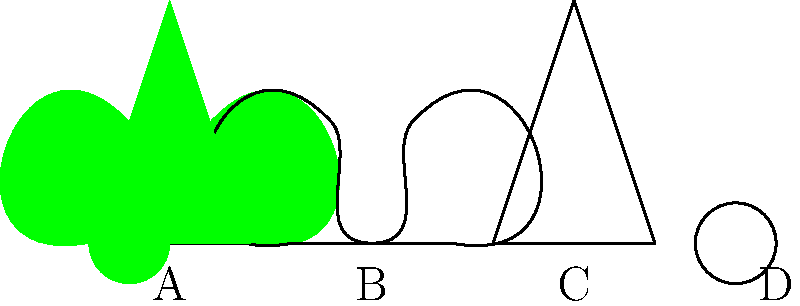In your therapeutic gardening program, you're teaching participants to identify plant species based on leaf shapes. Which of the leaf shapes shown above (A, B, C, or D) is most likely to belong to a maple tree, known for its distinctive lobed leaves? To identify the leaf shape most likely belonging to a maple tree, let's analyze each option:

1. Leaf A: This leaf has a simple, triangular shape with straight edges. It doesn't show any lobes or complex structure.

2. Leaf B: This leaf shows a clear lobed structure with multiple rounded projections along its edge. This is characteristic of many maple species, which typically have 3-5 lobes.

3. Leaf C: This leaf is elongated and narrow, with a simple shape similar to Leaf A but more stretched vertically. It doesn't show any lobes.

4. Leaf D: This leaf has a round, almost circular shape without any lobes or projections.

Maple trees are known for their distinctive lobed leaves, which typically have 3-5 lobes with serrated edges. Among the given options, only Leaf B exhibits this lobed structure, making it the most likely candidate for a maple leaf.

In therapeutic gardening programs, recognizing leaf shapes can be an engaging and educational activity for participants. It helps develop observational skills and connects individuals with nature, which can have calming and therapeutic effects.
Answer: B 